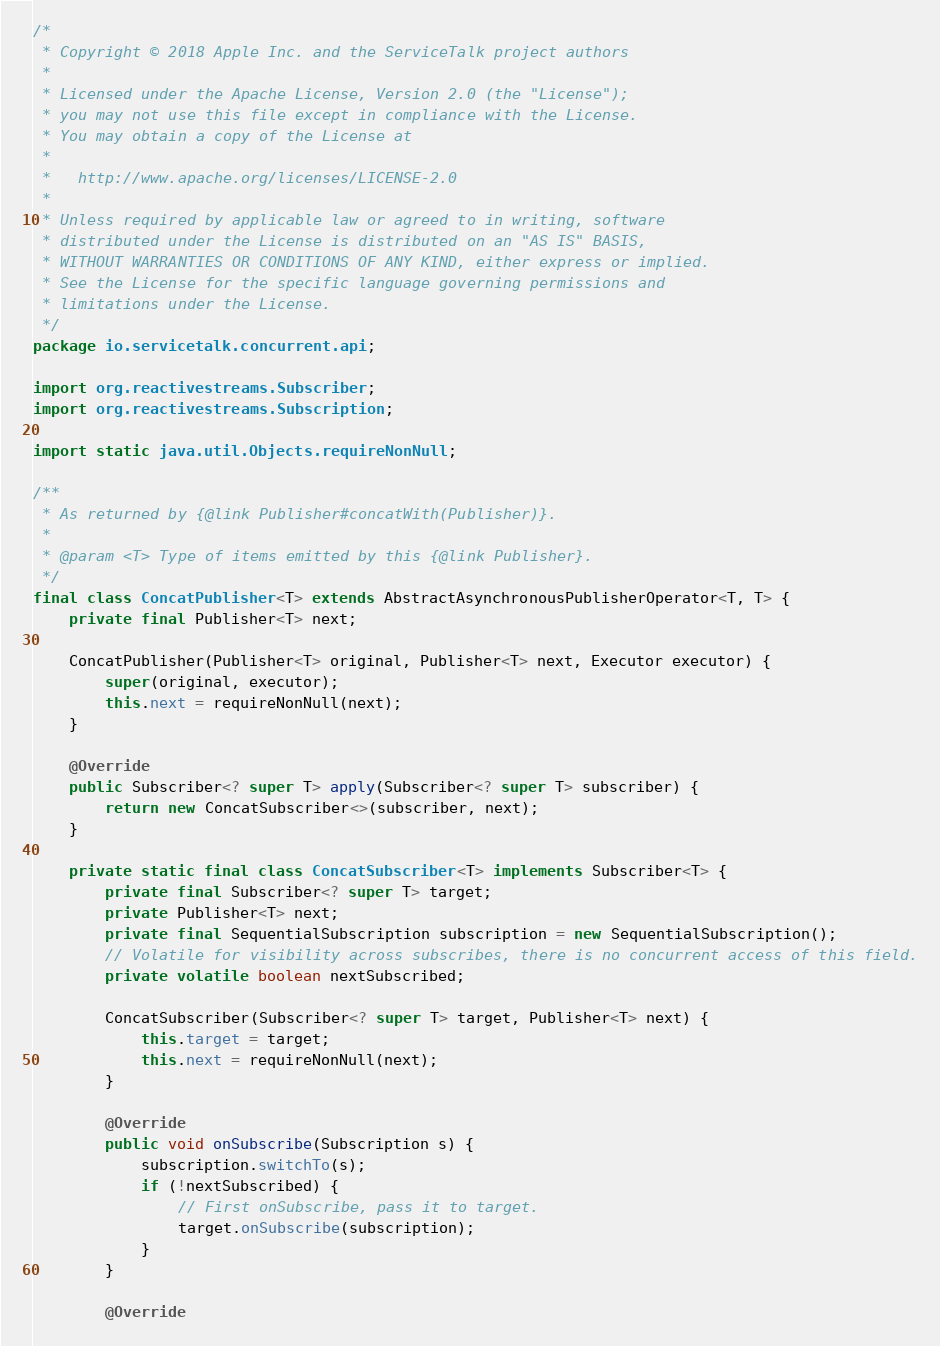<code> <loc_0><loc_0><loc_500><loc_500><_Java_>/*
 * Copyright © 2018 Apple Inc. and the ServiceTalk project authors
 *
 * Licensed under the Apache License, Version 2.0 (the "License");
 * you may not use this file except in compliance with the License.
 * You may obtain a copy of the License at
 *
 *   http://www.apache.org/licenses/LICENSE-2.0
 *
 * Unless required by applicable law or agreed to in writing, software
 * distributed under the License is distributed on an "AS IS" BASIS,
 * WITHOUT WARRANTIES OR CONDITIONS OF ANY KIND, either express or implied.
 * See the License for the specific language governing permissions and
 * limitations under the License.
 */
package io.servicetalk.concurrent.api;

import org.reactivestreams.Subscriber;
import org.reactivestreams.Subscription;

import static java.util.Objects.requireNonNull;

/**
 * As returned by {@link Publisher#concatWith(Publisher)}.
 *
 * @param <T> Type of items emitted by this {@link Publisher}.
 */
final class ConcatPublisher<T> extends AbstractAsynchronousPublisherOperator<T, T> {
    private final Publisher<T> next;

    ConcatPublisher(Publisher<T> original, Publisher<T> next, Executor executor) {
        super(original, executor);
        this.next = requireNonNull(next);
    }

    @Override
    public Subscriber<? super T> apply(Subscriber<? super T> subscriber) {
        return new ConcatSubscriber<>(subscriber, next);
    }

    private static final class ConcatSubscriber<T> implements Subscriber<T> {
        private final Subscriber<? super T> target;
        private Publisher<T> next;
        private final SequentialSubscription subscription = new SequentialSubscription();
        // Volatile for visibility across subscribes, there is no concurrent access of this field.
        private volatile boolean nextSubscribed;

        ConcatSubscriber(Subscriber<? super T> target, Publisher<T> next) {
            this.target = target;
            this.next = requireNonNull(next);
        }

        @Override
        public void onSubscribe(Subscription s) {
            subscription.switchTo(s);
            if (!nextSubscribed) {
                // First onSubscribe, pass it to target.
                target.onSubscribe(subscription);
            }
        }

        @Override</code> 